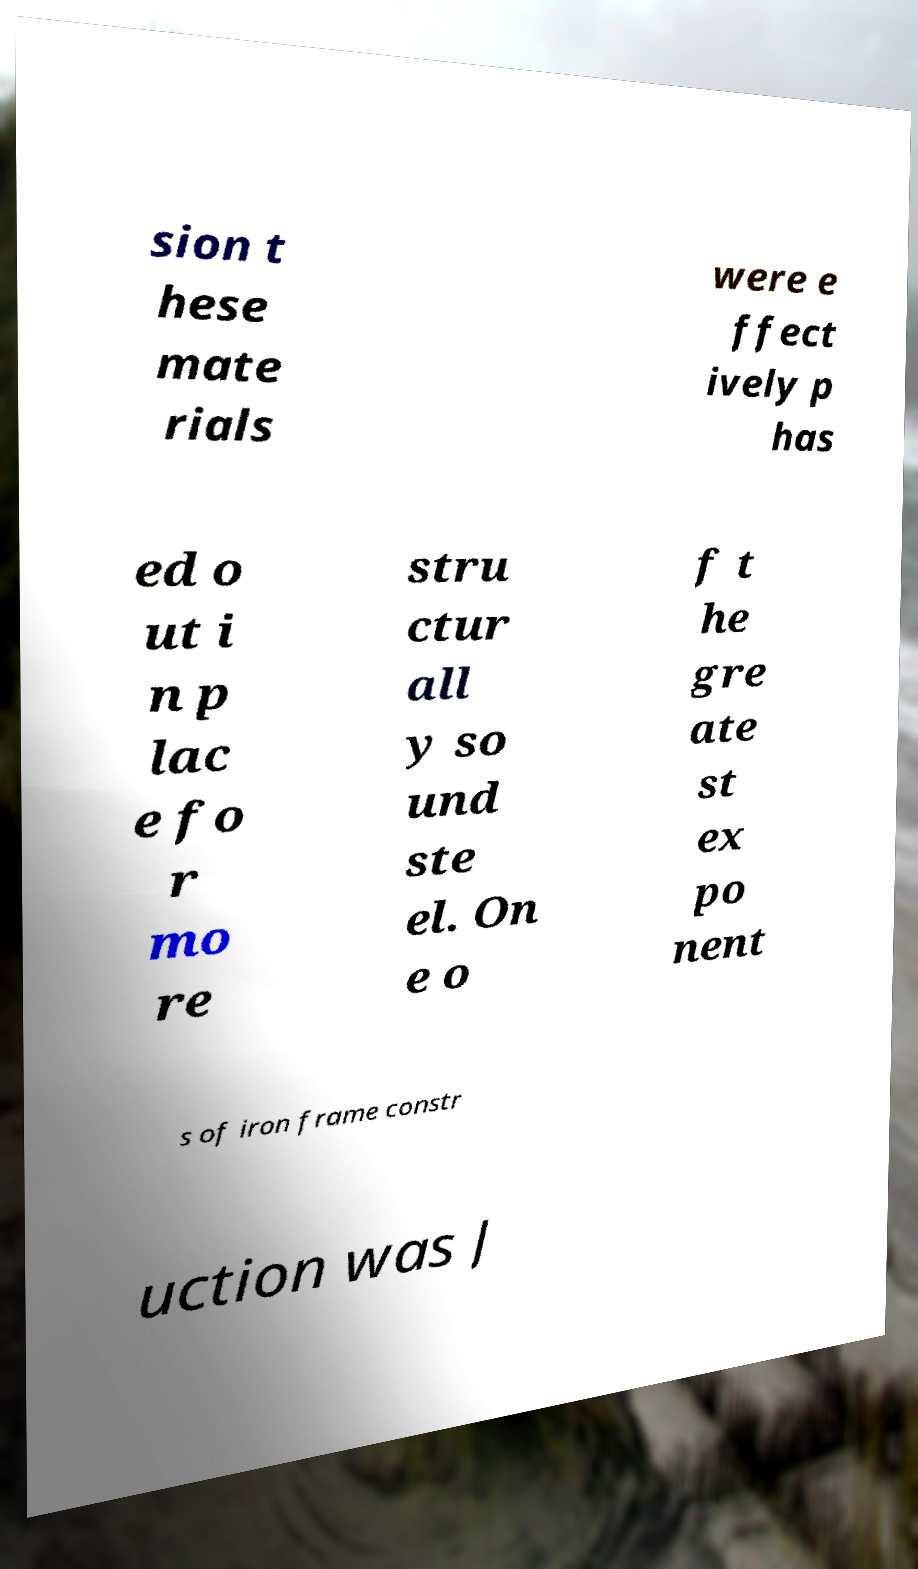Please read and relay the text visible in this image. What does it say? sion t hese mate rials were e ffect ively p has ed o ut i n p lac e fo r mo re stru ctur all y so und ste el. On e o f t he gre ate st ex po nent s of iron frame constr uction was J 